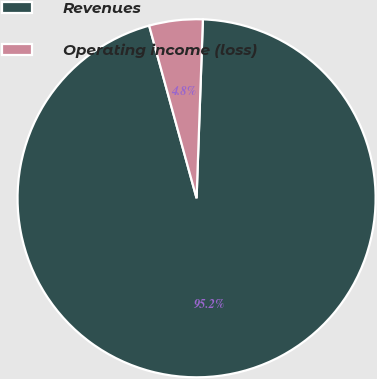<chart> <loc_0><loc_0><loc_500><loc_500><pie_chart><fcel>Revenues<fcel>Operating income (loss)<nl><fcel>95.17%<fcel>4.83%<nl></chart> 